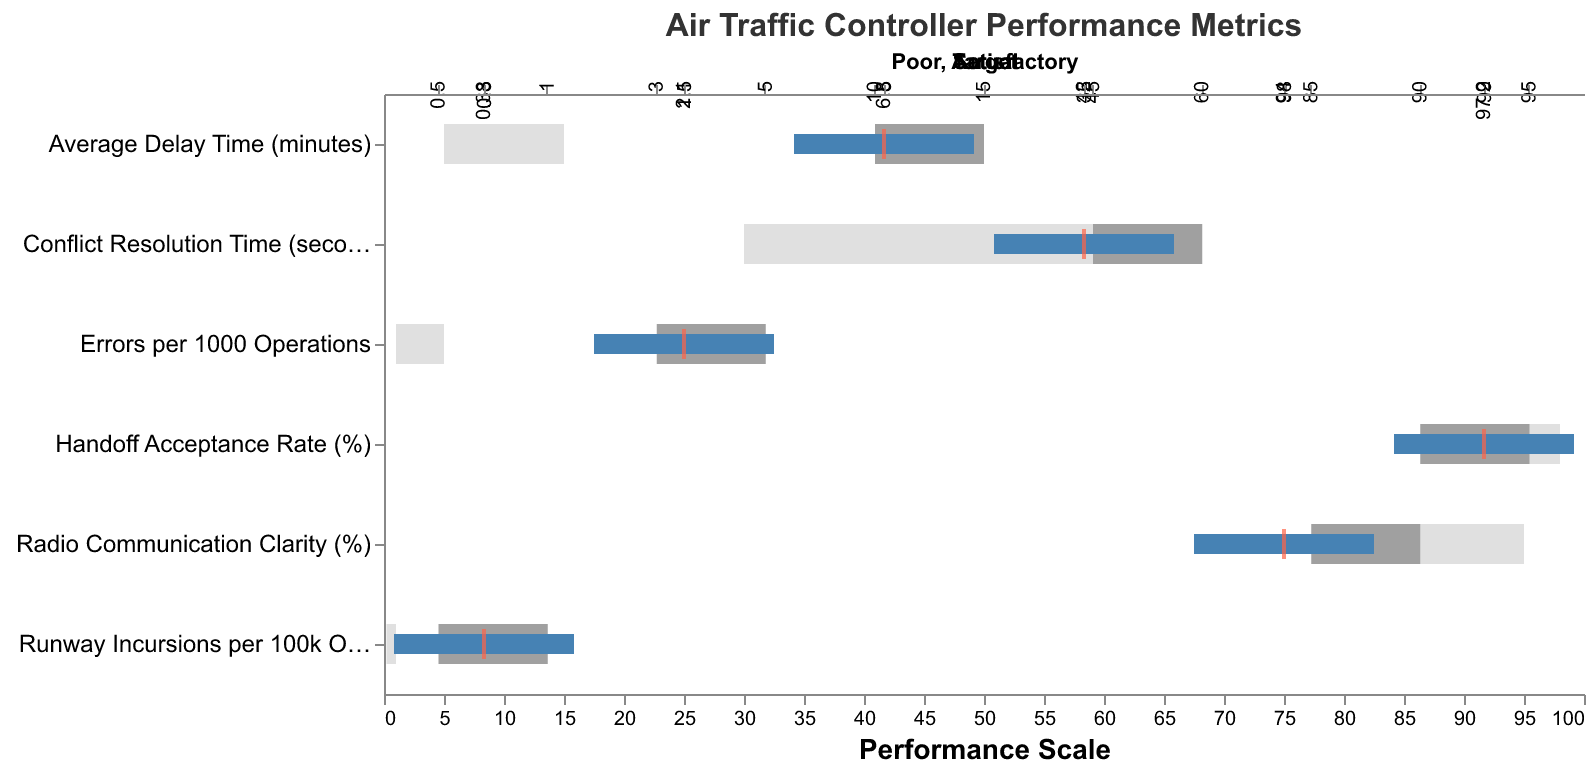What's the performance target for Errors per 1000 Operations? The target value is indicated by a red tick mark on the bullet chart specific to the Errors per 1000 Operations metric.
Answer: 1.5 How does the Actual performance on Average Delay Time compare to the target? The actual performance for Average Delay Time is indicated by a blue bar, and the target is denoted by a red tick mark. The actual value is 6.8 minutes, whereas the target is 5 minutes.
Answer: Worse than the target What is the range for the Poor classification for Conflict Resolution Time? The range for the Poor classification is shown as the light grey bar on the bullet chart within the Conflict Resolution Time metric. For this metric, the Poor classification starts at the baseline and goes up to 60 seconds.
Answer: 0 to 60 seconds What's the difference between the actual and excellent performance levels for Runway Incursions per 100k Operations? The actual performance is 0.38 and the excellent level is 0.2 for Runway Incursions per 100k Operations. To find the difference, subtract the excellent level from the actual level (0.38 - 0.2).
Answer: 0.18 For which metric is the actual performance the closest to its excellent level? Comparing the actual and excellent levels across all metrics, Errors per 1000 Operations (2.1/1) has a difference of 1.1, Average Delay Time (6.8/5) has a difference of 1.8, Conflict Resolution Time (42/30) has a difference of 12, Radio Communication Clarity (94/95) has a difference of 1, Runway Incursions per 100k Operations (0.38/0.2) has a difference of 0.18, and Handoff Acceptance Rate (97.2/98) has a difference of 0.8. The closest difference is for Runway Incursions per 100k Operations.
Answer: Runway Incursions per 100k Operations Which metric's actual performance is the farthest from the target? By examining each metric's bullet chart, the largest distance between actual (blue bar) and target (red tick) should be identified. Errors per 1000 Operations: difference of 0.6, Average Delay Time: difference of 1.8, Conflict Resolution Time: difference of 7, Radio Communication Clarity: difference of 4, Runway Incursions per 100k Operations: difference of 0.08, Handoff Acceptance Rate: difference of 1.8. The largest difference is for Conflict Resolution Time.
Answer: Conflict Resolution Time How many metrics are meeting or performing better than their target values? By visually checking each metric's actual performance against their target values: Errors per 1000 Operations (not meeting), Average Delay Time (not meeting), Conflict Resolution Time (not meeting), Radio Communication Clarity (not meeting), Runway Incursions per 100k Operations (meeting), Handoff Acceptance Rate (not meeting). So only one metric is meeting or performing better than the target value.
Answer: 1 What's the gap between the target and actual performance for Radio Communication Clarity? The actual performance for Radio Communication Clarity is 94%, and the target is 98%. Subtract the actual value from the target value (98 - 94).
Answer: 4% 